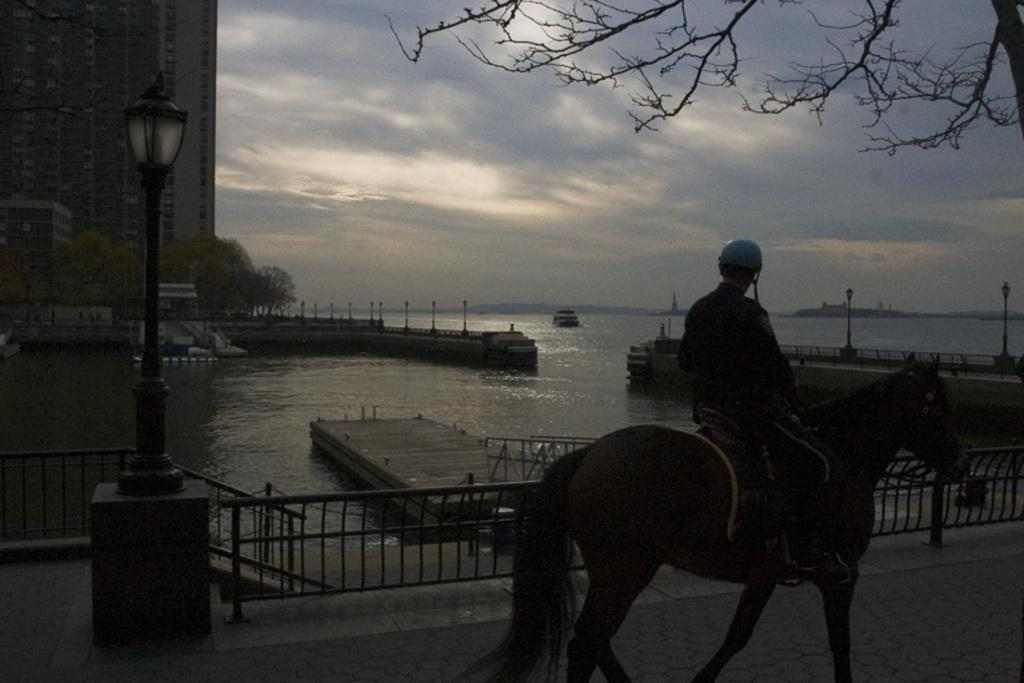Who is the main subject in the image? There is a man in the image. What is the man doing in the image? The man is sitting on a horse. What is the condition of the sky in the image? The sky is clear in the image. What natural feature can be seen in the image? There is a river in the image. How many pigs are swimming in the river in the image? There are no pigs present in the image; it features a man sitting on a horse and a clear sky. What type of tiger can be seen walking along the riverbank in the image? There is no tiger present in the image; it only features a man sitting on a horse, a clear sky, and a river. 